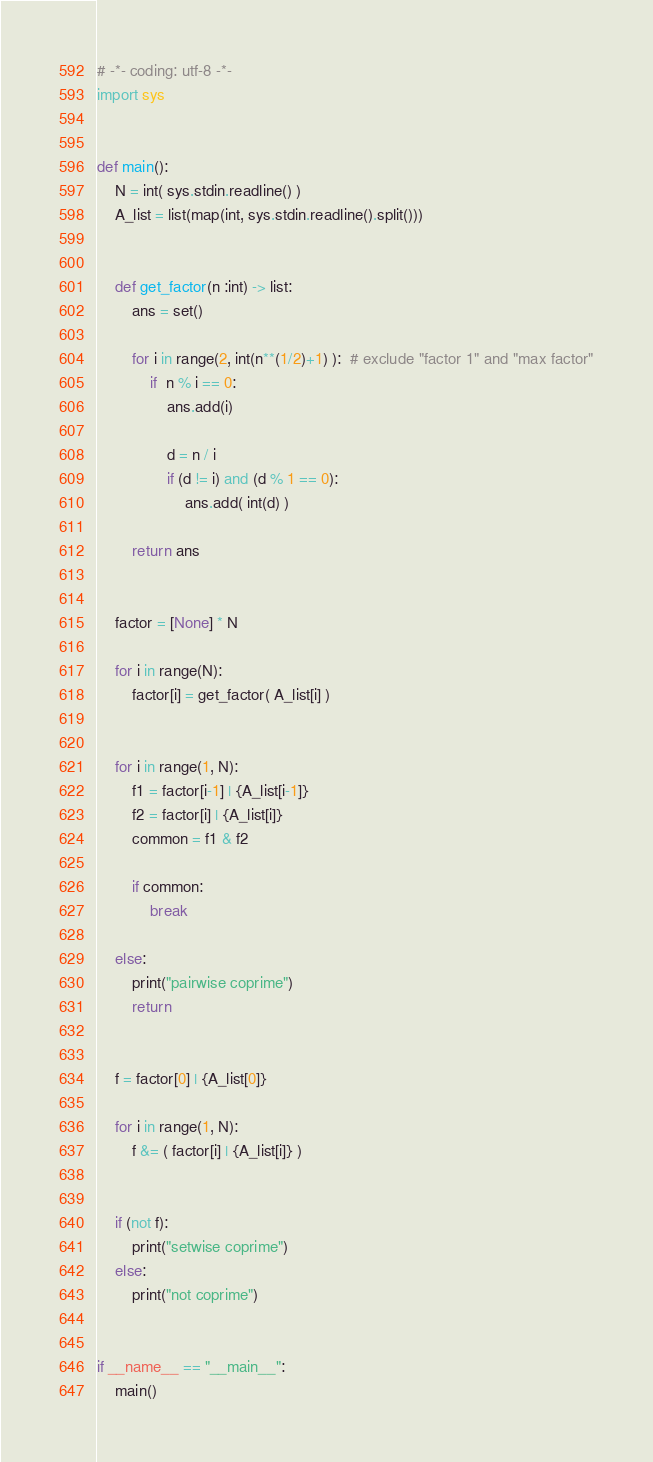Convert code to text. <code><loc_0><loc_0><loc_500><loc_500><_Python_># -*- coding: utf-8 -*-
import sys


def main():
    N = int( sys.stdin.readline() )
    A_list = list(map(int, sys.stdin.readline().split()))


    def get_factor(n :int) -> list:
        ans = set()
        
        for i in range(2, int(n**(1/2)+1) ):  # exclude "factor 1" and "max factor"
            if  n % i == 0:
                ans.add(i)
                
                d = n / i
                if (d != i) and (d % 1 == 0):
                    ans.add( int(d) )
        
        return ans


    factor = [None] * N

    for i in range(N):
        factor[i] = get_factor( A_list[i] )
    

    for i in range(1, N):
        f1 = factor[i-1] | {A_list[i-1]}
        f2 = factor[i] | {A_list[i]}
        common = f1 & f2

        if common:
            break
    
    else:
        print("pairwise coprime")
        return


    f = factor[0] | {A_list[0]}

    for i in range(1, N):
        f &= ( factor[i] | {A_list[i]} )
    
    
    if (not f):
        print("setwise coprime")
    else:
        print("not coprime")


if __name__ == "__main__":
    main()
</code> 